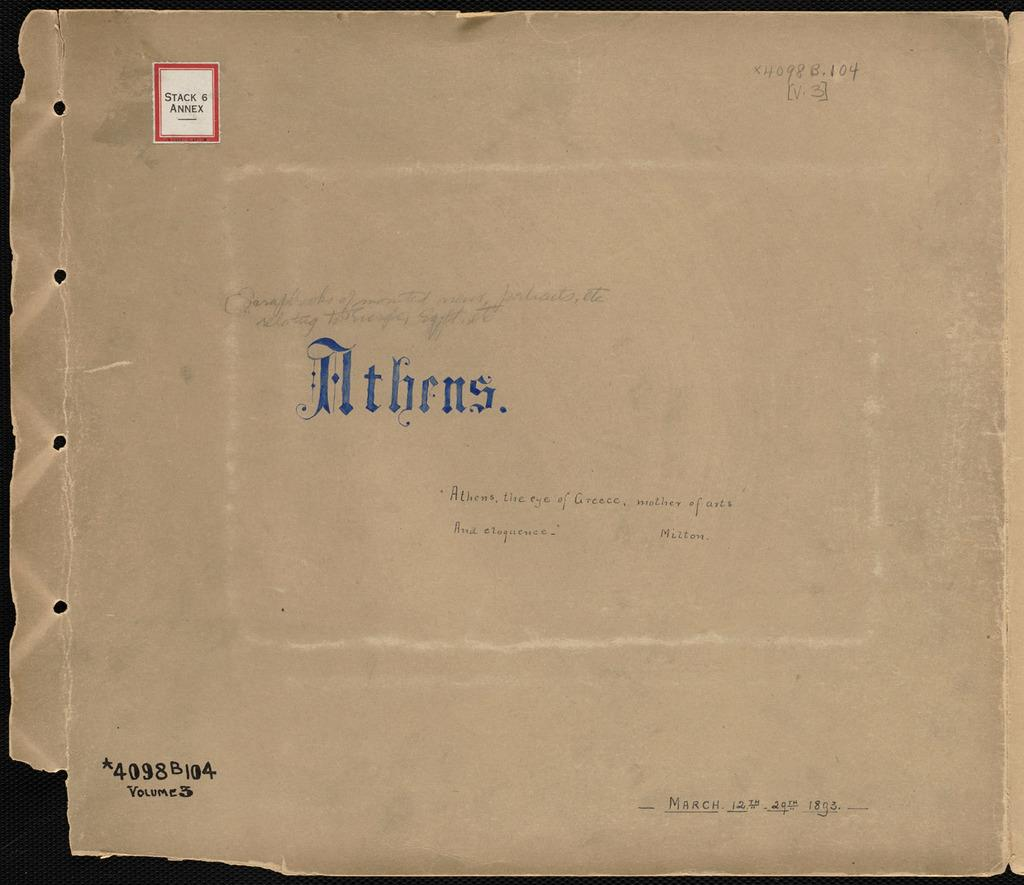<image>
Summarize the visual content of the image. A very old brown cover that has the word Athens inscribed on it. 